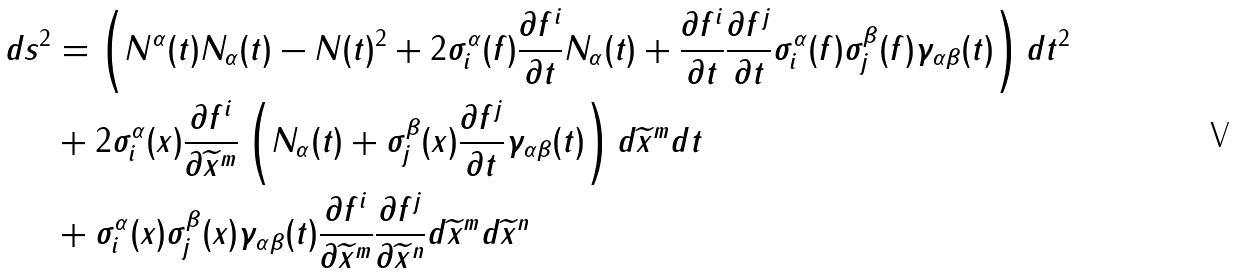<formula> <loc_0><loc_0><loc_500><loc_500>d s ^ { 2 } & = \left ( N ^ { \alpha } ( t ) N _ { \alpha } ( t ) - N ( t ) ^ { 2 } + 2 \sigma ^ { \alpha } _ { i } ( f ) \frac { \partial f ^ { i } } { \partial t } N _ { \alpha } ( t ) + \frac { \partial f ^ { i } } { \partial t } \frac { \partial f ^ { j } } { \partial t } \sigma ^ { \alpha } _ { i } ( f ) \sigma ^ { \beta } _ { j } ( f ) \gamma _ { \alpha \beta } ( t ) \right ) d t ^ { 2 } \\ & + 2 \sigma ^ { \alpha } _ { i } ( x ) \frac { \partial f ^ { i } } { \partial \widetilde { x } ^ { m } } \left ( N _ { \alpha } ( t ) + \sigma ^ { \beta } _ { j } ( x ) \frac { \partial f ^ { j } } { \partial t } \gamma _ { \alpha \beta } ( t ) \right ) d \widetilde { x } ^ { m } d t \\ & + \sigma ^ { \alpha } _ { i } ( x ) \sigma ^ { \beta } _ { j } ( x ) \gamma _ { \alpha \beta } ( t ) \frac { \partial f ^ { i } } { \partial \widetilde { x } ^ { m } } \frac { \partial f ^ { j } } { \partial \widetilde { x } ^ { n } } d \widetilde { x } ^ { m } d \widetilde { x } ^ { n }</formula> 